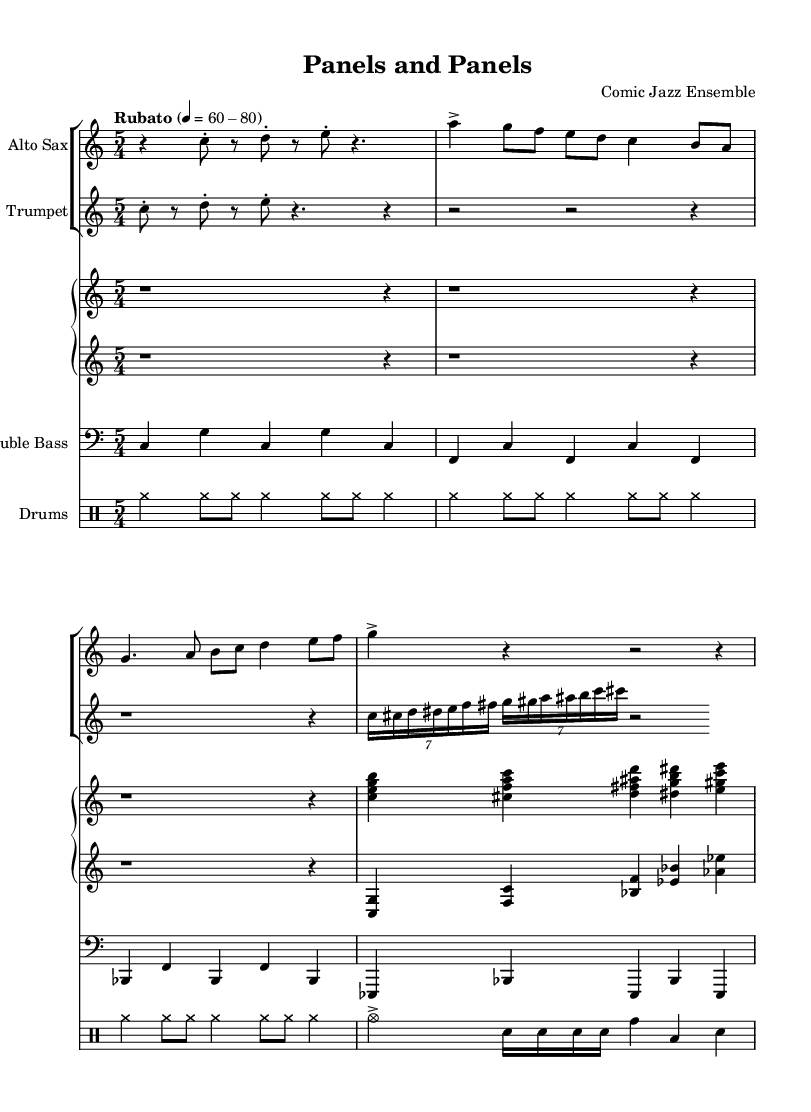What is the time signature of this music? The time signature is written at the beginning of the music as 5/4, indicating that there are five beats per measure and a quarter note receives one beat.
Answer: 5/4 What is the tempo marking indicated in the sheet music? The tempo marking specifies "Rubato" with a range of 60-80 beats per minute, indicating a flexible tempo that allows expressive timing.
Answer: Rubato 60-80 How many bars does the saxophone part have? Counting the measures in the saxophone part, there are 4 bars present in total.
Answer: 4 What instruments are featured in this jazz ensemble? By looking at the individual parts listed, the instruments included are Alto Sax, Trumpet, Piano (with right and left hands), Double Bass, and Drums.
Answer: Alto Sax, Trumpet, Piano, Double Bass, Drums What is the rhythmic feel of the drum part in the opening measures? The drum part alternates between cymbal hits and snare, reflecting a typical jazz rhythm with a focus on keeping time while allowing for dynamics.
Answer: Jazz rhythm How is the piano classified in the score? The piano staff is clearly labeled as "Piano" with two staves designated as "upper" and "lower," indicating the right and left hand parts respectively.
Answer: Piano upper, lower 